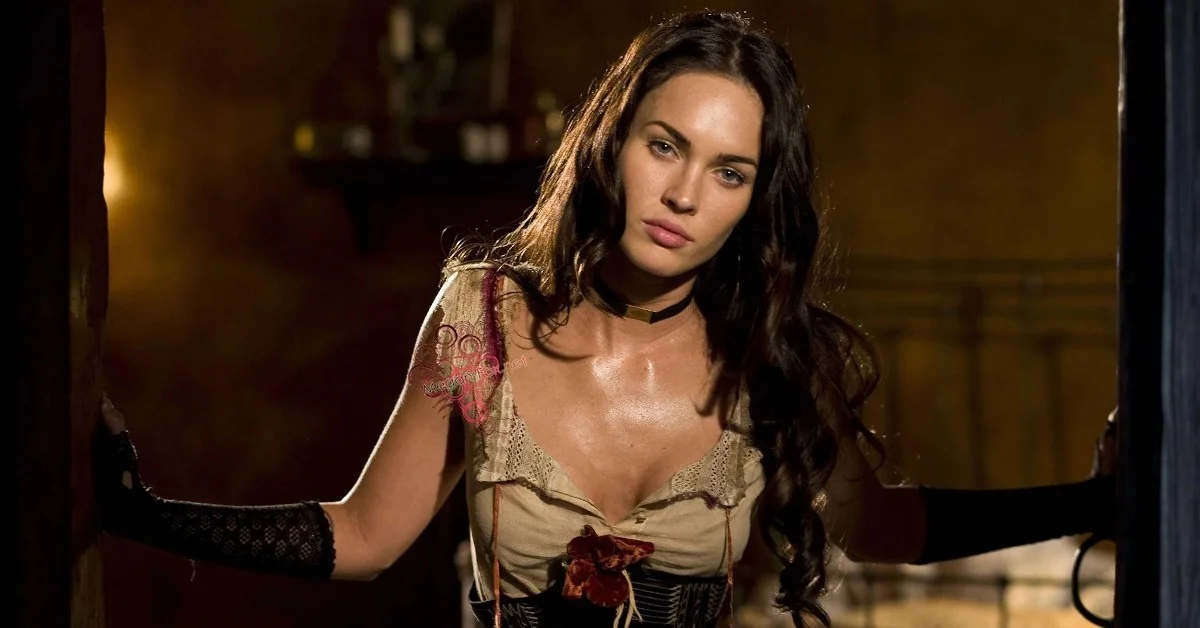Discuss the possible symbolic meaning of the red rose in her attire. The red rose in her attire could symbolize several concepts. Traditionally, a red rose is often associated with love, passion, and romance. In the context of her dramatic and potentially theatrical setting, the rose might signify a deep, passionate character trait or a subplot involving love or betrayal. Additionally, the rose could be a focal point used to draw attention to the intricacy and thematic depth of her costume, suggesting that her character or role might pivot around themes of love and emotion. 